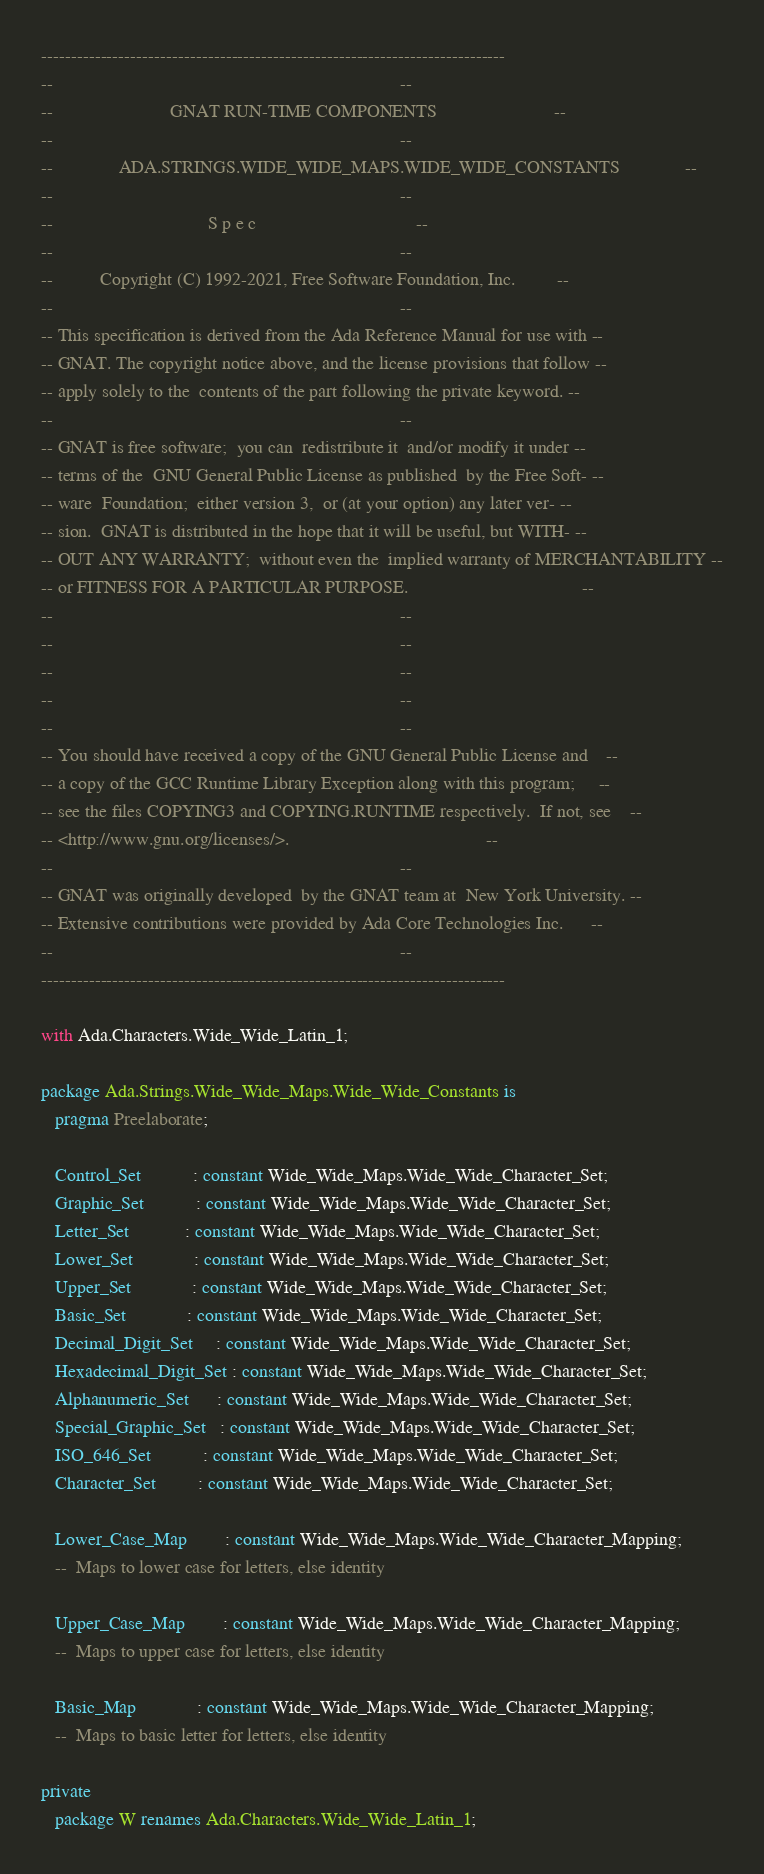<code> <loc_0><loc_0><loc_500><loc_500><_Ada_>------------------------------------------------------------------------------
--                                                                          --
--                         GNAT RUN-TIME COMPONENTS                         --
--                                                                          --
--              ADA.STRINGS.WIDE_WIDE_MAPS.WIDE_WIDE_CONSTANTS              --
--                                                                          --
--                                 S p e c                                  --
--                                                                          --
--          Copyright (C) 1992-2021, Free Software Foundation, Inc.         --
--                                                                          --
-- This specification is derived from the Ada Reference Manual for use with --
-- GNAT. The copyright notice above, and the license provisions that follow --
-- apply solely to the  contents of the part following the private keyword. --
--                                                                          --
-- GNAT is free software;  you can  redistribute it  and/or modify it under --
-- terms of the  GNU General Public License as published  by the Free Soft- --
-- ware  Foundation;  either version 3,  or (at your option) any later ver- --
-- sion.  GNAT is distributed in the hope that it will be useful, but WITH- --
-- OUT ANY WARRANTY;  without even the  implied warranty of MERCHANTABILITY --
-- or FITNESS FOR A PARTICULAR PURPOSE.                                     --
--                                                                          --
--                                                                          --
--                                                                          --
--                                                                          --
--                                                                          --
-- You should have received a copy of the GNU General Public License and    --
-- a copy of the GCC Runtime Library Exception along with this program;     --
-- see the files COPYING3 and COPYING.RUNTIME respectively.  If not, see    --
-- <http://www.gnu.org/licenses/>.                                          --
--                                                                          --
-- GNAT was originally developed  by the GNAT team at  New York University. --
-- Extensive contributions were provided by Ada Core Technologies Inc.      --
--                                                                          --
------------------------------------------------------------------------------

with Ada.Characters.Wide_Wide_Latin_1;

package Ada.Strings.Wide_Wide_Maps.Wide_Wide_Constants is
   pragma Preelaborate;

   Control_Set           : constant Wide_Wide_Maps.Wide_Wide_Character_Set;
   Graphic_Set           : constant Wide_Wide_Maps.Wide_Wide_Character_Set;
   Letter_Set            : constant Wide_Wide_Maps.Wide_Wide_Character_Set;
   Lower_Set             : constant Wide_Wide_Maps.Wide_Wide_Character_Set;
   Upper_Set             : constant Wide_Wide_Maps.Wide_Wide_Character_Set;
   Basic_Set             : constant Wide_Wide_Maps.Wide_Wide_Character_Set;
   Decimal_Digit_Set     : constant Wide_Wide_Maps.Wide_Wide_Character_Set;
   Hexadecimal_Digit_Set : constant Wide_Wide_Maps.Wide_Wide_Character_Set;
   Alphanumeric_Set      : constant Wide_Wide_Maps.Wide_Wide_Character_Set;
   Special_Graphic_Set   : constant Wide_Wide_Maps.Wide_Wide_Character_Set;
   ISO_646_Set           : constant Wide_Wide_Maps.Wide_Wide_Character_Set;
   Character_Set         : constant Wide_Wide_Maps.Wide_Wide_Character_Set;

   Lower_Case_Map        : constant Wide_Wide_Maps.Wide_Wide_Character_Mapping;
   --  Maps to lower case for letters, else identity

   Upper_Case_Map        : constant Wide_Wide_Maps.Wide_Wide_Character_Mapping;
   --  Maps to upper case for letters, else identity

   Basic_Map             : constant Wide_Wide_Maps.Wide_Wide_Character_Mapping;
   --  Maps to basic letter for letters, else identity

private
   package W renames Ada.Characters.Wide_Wide_Latin_1;
</code> 